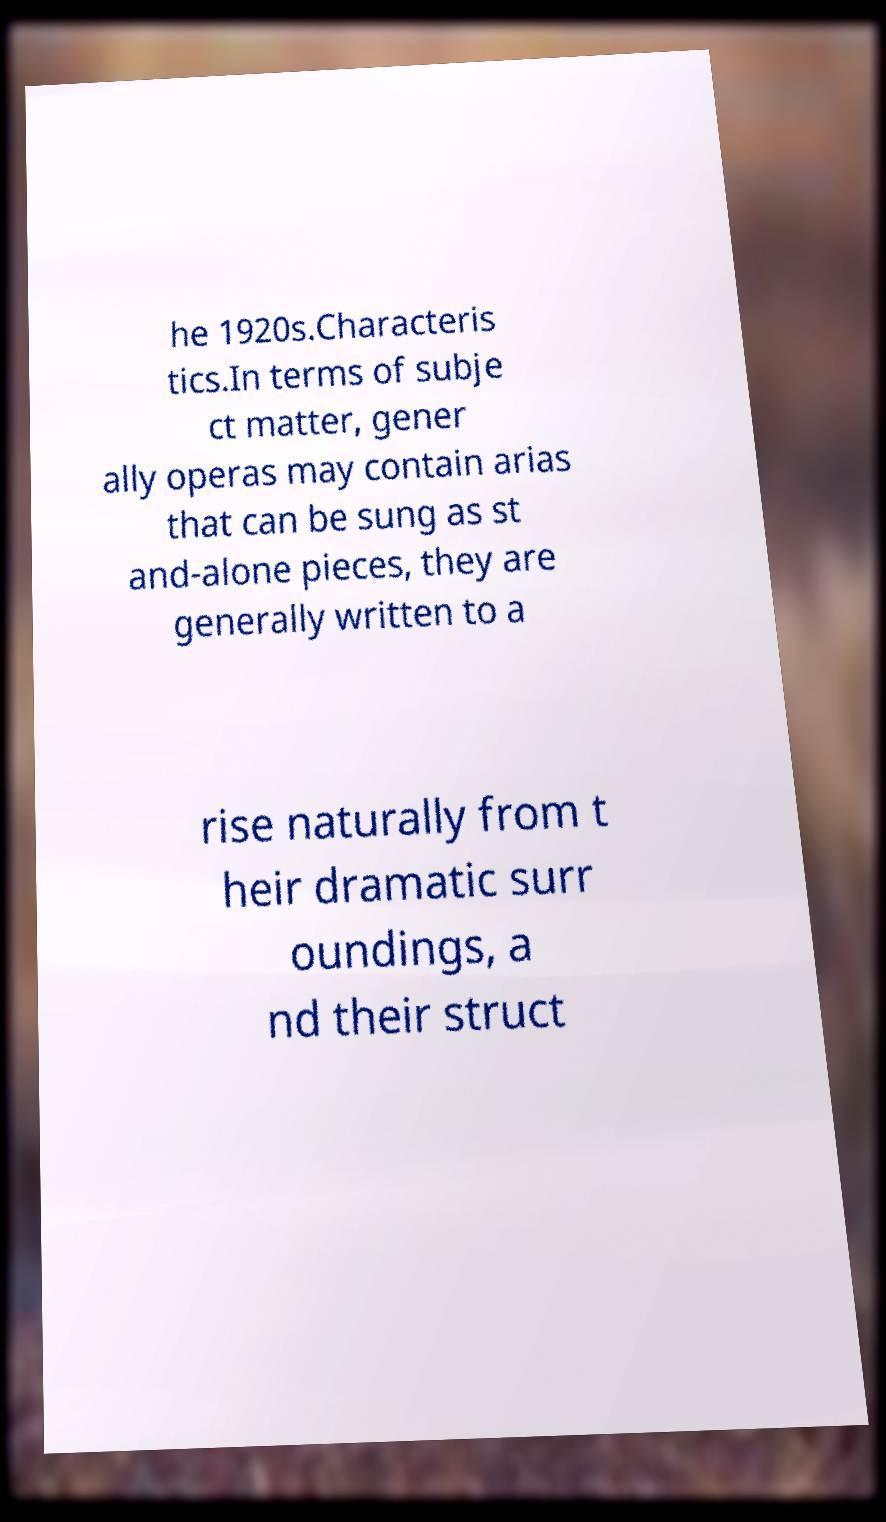I need the written content from this picture converted into text. Can you do that? he 1920s.Characteris tics.In terms of subje ct matter, gener ally operas may contain arias that can be sung as st and-alone pieces, they are generally written to a rise naturally from t heir dramatic surr oundings, a nd their struct 